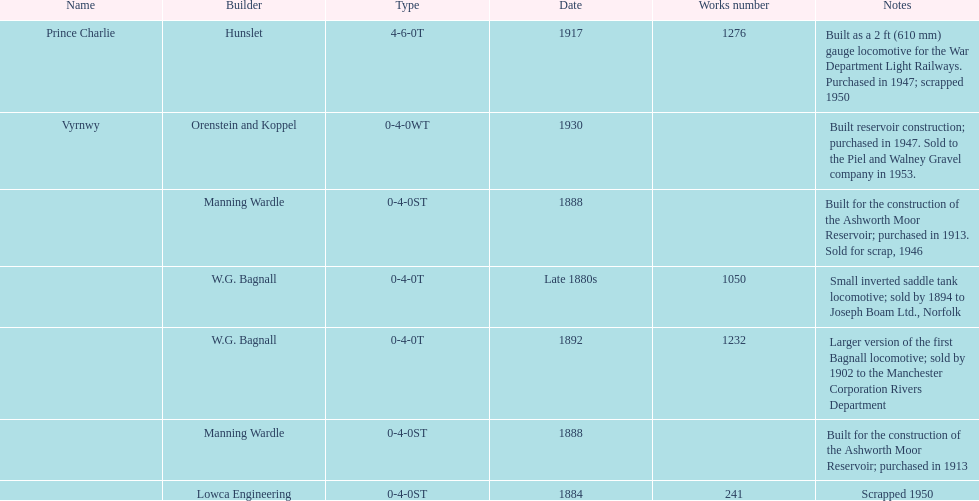How many locomotives were built for the construction of the ashworth moor reservoir? 2. 